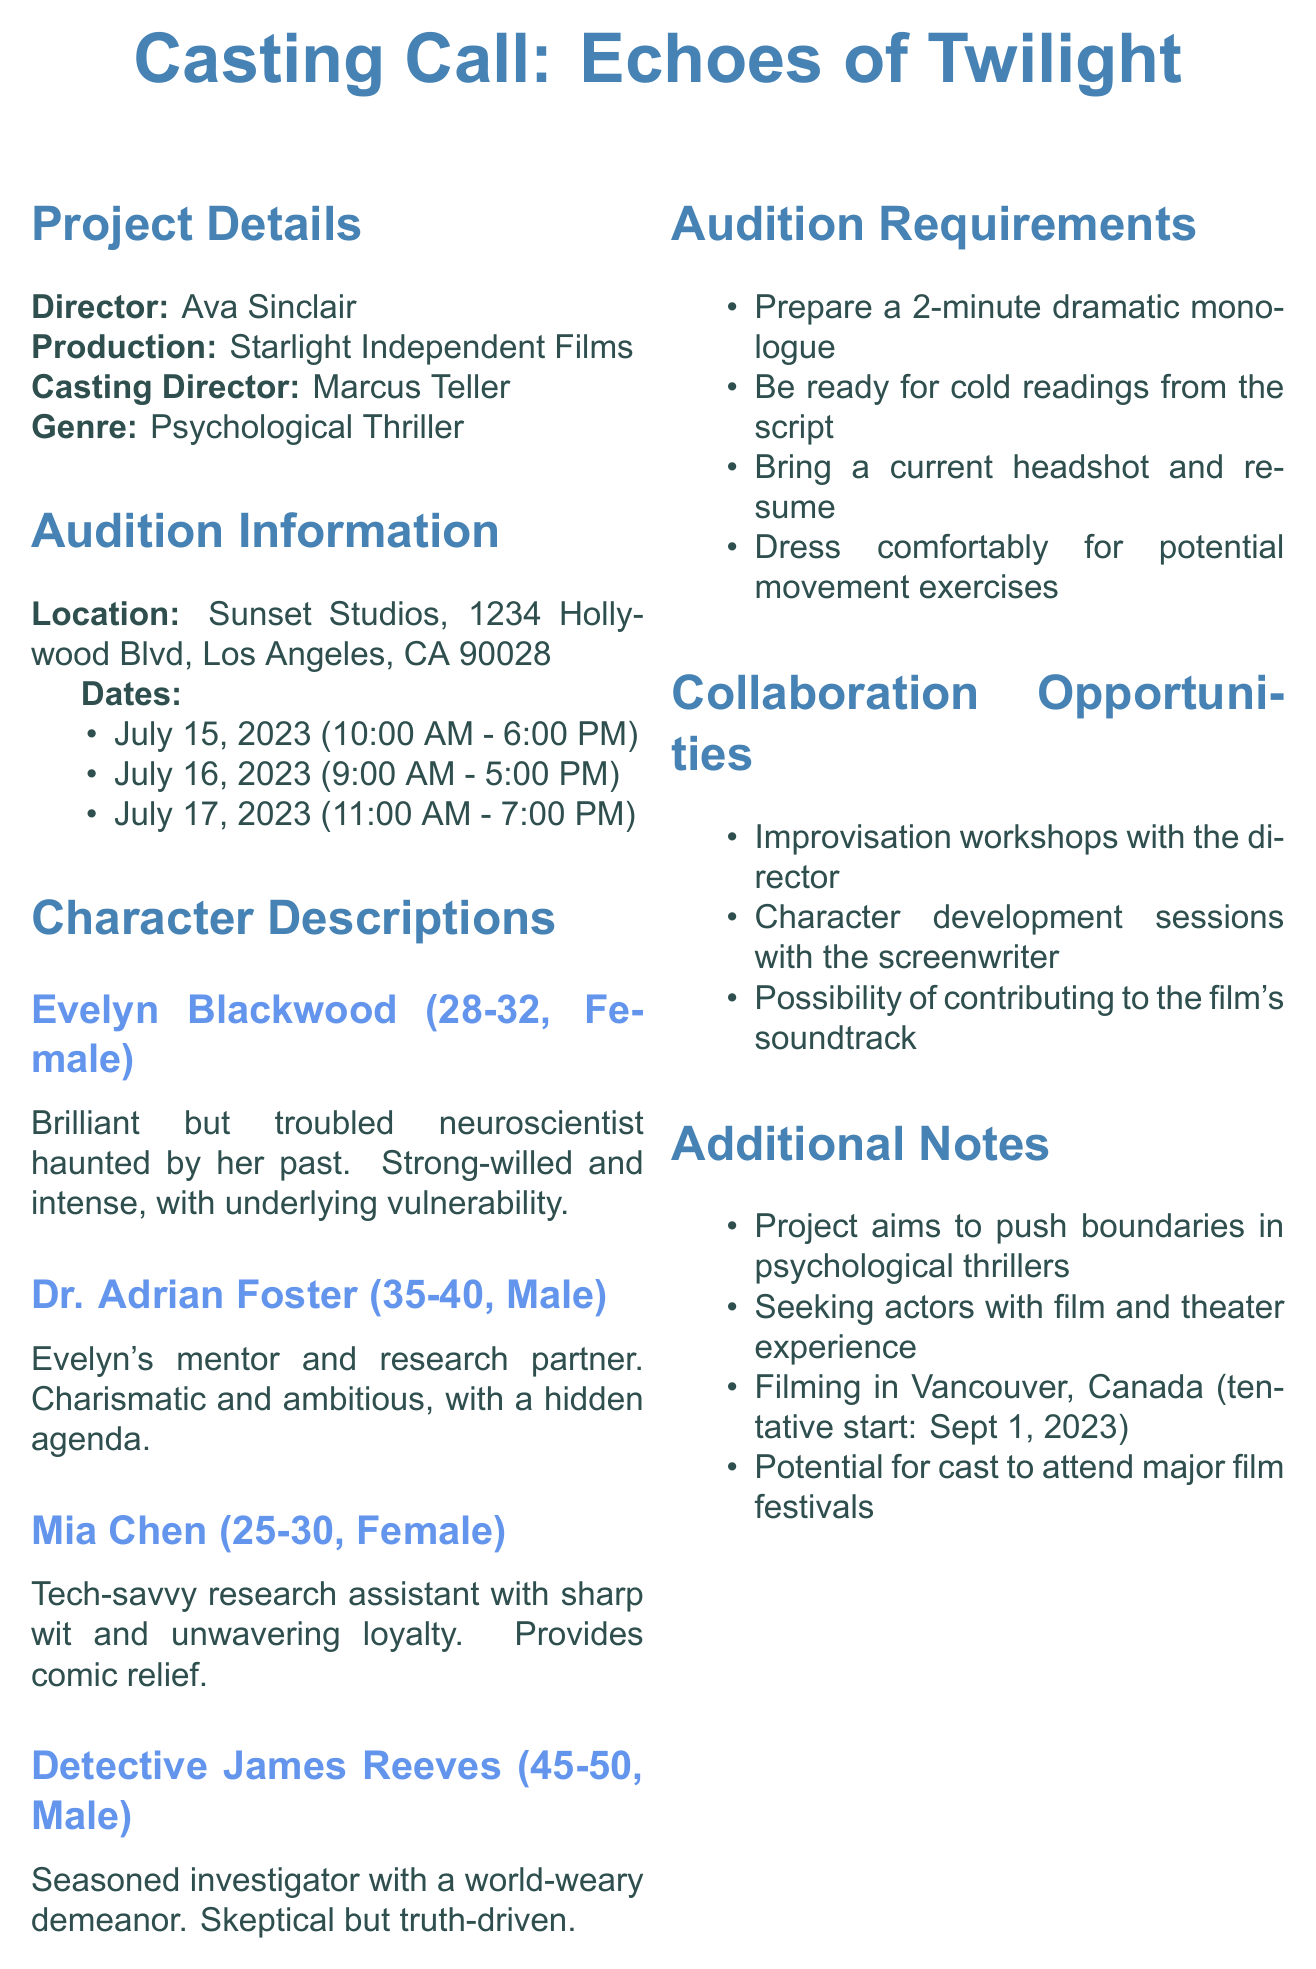What is the title of the film? The title of the film is listed at the beginning of the memo.
Answer: Echoes of Twilight Who is the director? The director's name is provided in the project details section of the memo.
Answer: Ava Sinclair What are the audition dates? The specific dates for auditions are stated in the audition information section.
Answer: July 15-17, 2023 What character is described as a tech-savvy research assistant? The character descriptions section provides details about each character, including their traits.
Answer: Mia Chen How long should the dramatic monologue be? The audition requirements specify the duration of the monologue to prepare for auditions.
Answer: 2 minutes What is the film genre? The genre of the film is mentioned in the project details section.
Answer: Psychological Thriller What location will the auditions be held? The audition location is explicitly stated in the audition information section.
Answer: Sunset Studios, 1234 Hollywood Blvd, Los Angeles, CA 90028 What collaboration opportunity is available with the director? The document lists various collaboration opportunities, including working with the director.
Answer: Improvisation workshops How old should the character Evelyn Blackwood be? The character descriptions section provides specific age ranges for each character listed.
Answer: 28-32 